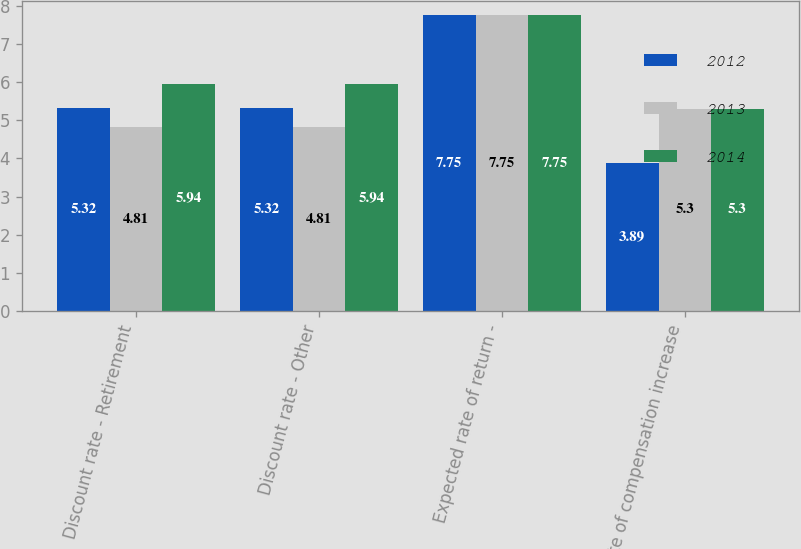<chart> <loc_0><loc_0><loc_500><loc_500><stacked_bar_chart><ecel><fcel>Discount rate - Retirement<fcel>Discount rate - Other<fcel>Expected rate of return -<fcel>Rate of compensation increase<nl><fcel>2012<fcel>5.32<fcel>5.32<fcel>7.75<fcel>3.89<nl><fcel>2013<fcel>4.81<fcel>4.81<fcel>7.75<fcel>5.3<nl><fcel>2014<fcel>5.94<fcel>5.94<fcel>7.75<fcel>5.3<nl></chart> 